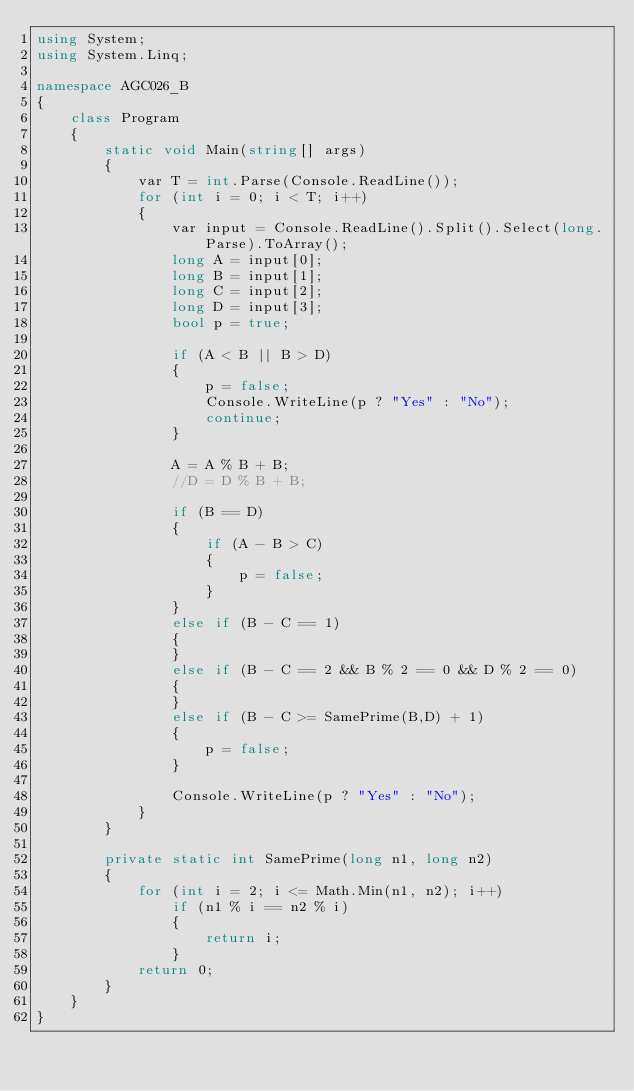<code> <loc_0><loc_0><loc_500><loc_500><_C#_>using System;
using System.Linq;

namespace AGC026_B
{
    class Program
    {
        static void Main(string[] args)
        {
            var T = int.Parse(Console.ReadLine());
            for (int i = 0; i < T; i++)
            {
                var input = Console.ReadLine().Split().Select(long.Parse).ToArray();
                long A = input[0];
                long B = input[1];
                long C = input[2];
                long D = input[3];
                bool p = true;

                if (A < B || B > D)
                {
                    p = false;
                    Console.WriteLine(p ? "Yes" : "No");
                    continue;
                }

                A = A % B + B;
                //D = D % B + B;

                if (B == D)
                {
                    if (A - B > C)
                    {
                        p = false;
                    }
                }
                else if (B - C == 1)
                {
                }
                else if (B - C == 2 && B % 2 == 0 && D % 2 == 0)
                {
                }
                else if (B - C >= SamePrime(B,D) + 1)
                {
                    p = false;
                }

                Console.WriteLine(p ? "Yes" : "No");
            }
        }

        private static int SamePrime(long n1, long n2)
        {
            for (int i = 2; i <= Math.Min(n1, n2); i++)
                if (n1 % i == n2 % i)
                {
                    return i;
                }
            return 0;
        }
    }
}
</code> 